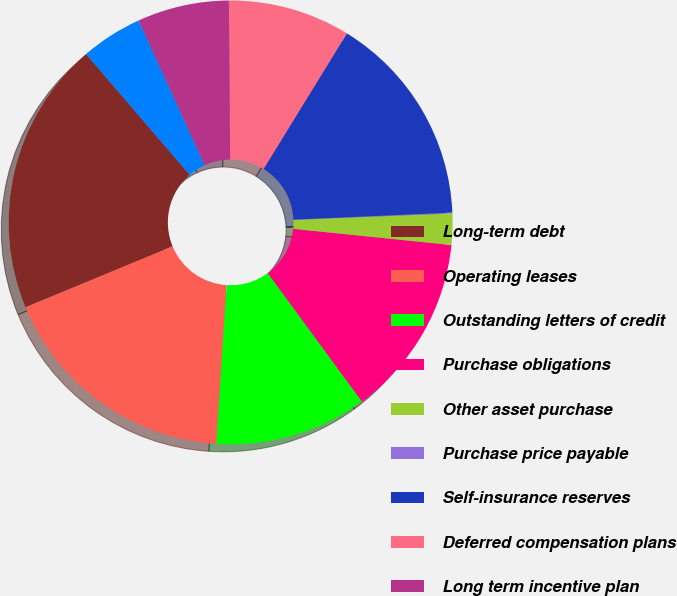Convert chart to OTSL. <chart><loc_0><loc_0><loc_500><loc_500><pie_chart><fcel>Long-term debt<fcel>Operating leases<fcel>Outstanding letters of credit<fcel>Purchase obligations<fcel>Other asset purchase<fcel>Purchase price payable<fcel>Self-insurance reserves<fcel>Deferred compensation plans<fcel>Long term incentive plan<fcel>Liabilities for unrecognized<nl><fcel>19.94%<fcel>17.73%<fcel>11.1%<fcel>13.31%<fcel>2.27%<fcel>0.06%<fcel>15.52%<fcel>8.9%<fcel>6.69%<fcel>4.48%<nl></chart> 